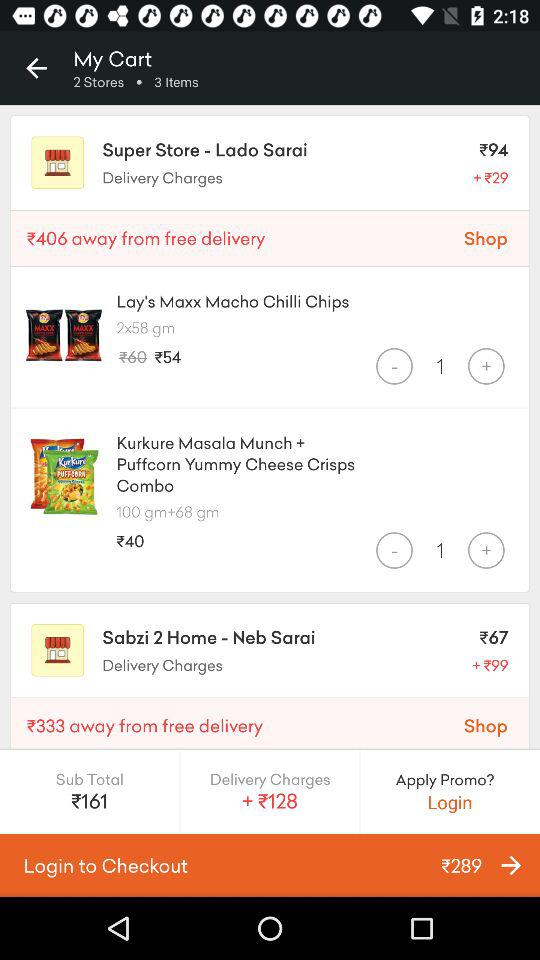What are the delivery charges for the Super Store - Lado Sarai? The delivery charges are ₹128. 